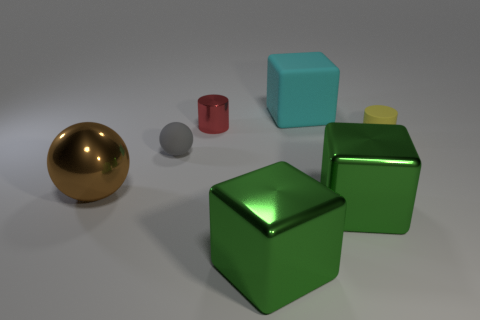What is the shape of the large thing that is made of the same material as the tiny gray sphere?
Give a very brief answer. Cube. Is there any other thing that has the same color as the matte cylinder?
Offer a very short reply. No. The metal object that is behind the tiny thing to the right of the large cyan rubber thing is what color?
Provide a short and direct response. Red. How many large objects are either green shiny blocks or cylinders?
Give a very brief answer. 2. There is another thing that is the same shape as the brown metal thing; what material is it?
Your answer should be very brief. Rubber. What is the color of the metallic cylinder?
Give a very brief answer. Red. There is a big thing behind the big brown shiny sphere; what number of large cyan things are on the left side of it?
Your answer should be compact. 0. There is a thing that is to the left of the red cylinder and to the right of the large brown metal object; what is its size?
Make the answer very short. Small. There is a big thing that is to the left of the small metal cylinder; what is it made of?
Provide a succinct answer. Metal. Are there any big brown objects of the same shape as the cyan rubber thing?
Make the answer very short. No. 